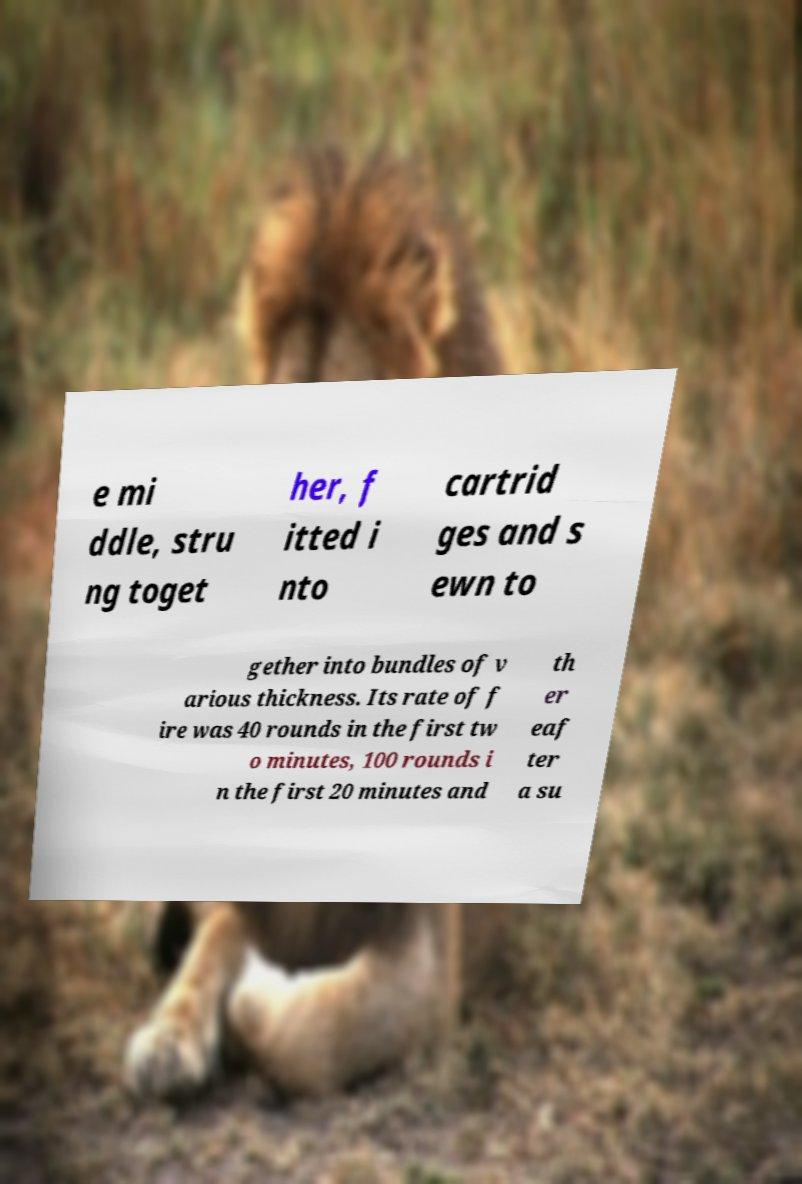Can you read and provide the text displayed in the image?This photo seems to have some interesting text. Can you extract and type it out for me? e mi ddle, stru ng toget her, f itted i nto cartrid ges and s ewn to gether into bundles of v arious thickness. Its rate of f ire was 40 rounds in the first tw o minutes, 100 rounds i n the first 20 minutes and th er eaf ter a su 